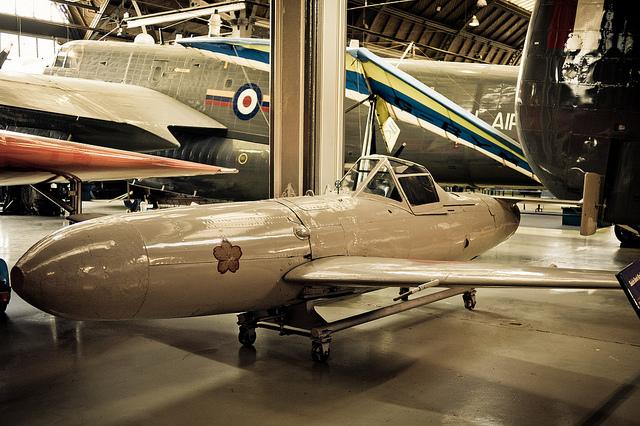Is this a museum?
Quick response, please. Yes. What is stored in this building?
Give a very brief answer. Airplanes. What colors are the circle on the plane?
Concise answer only. Blue, white and red. 